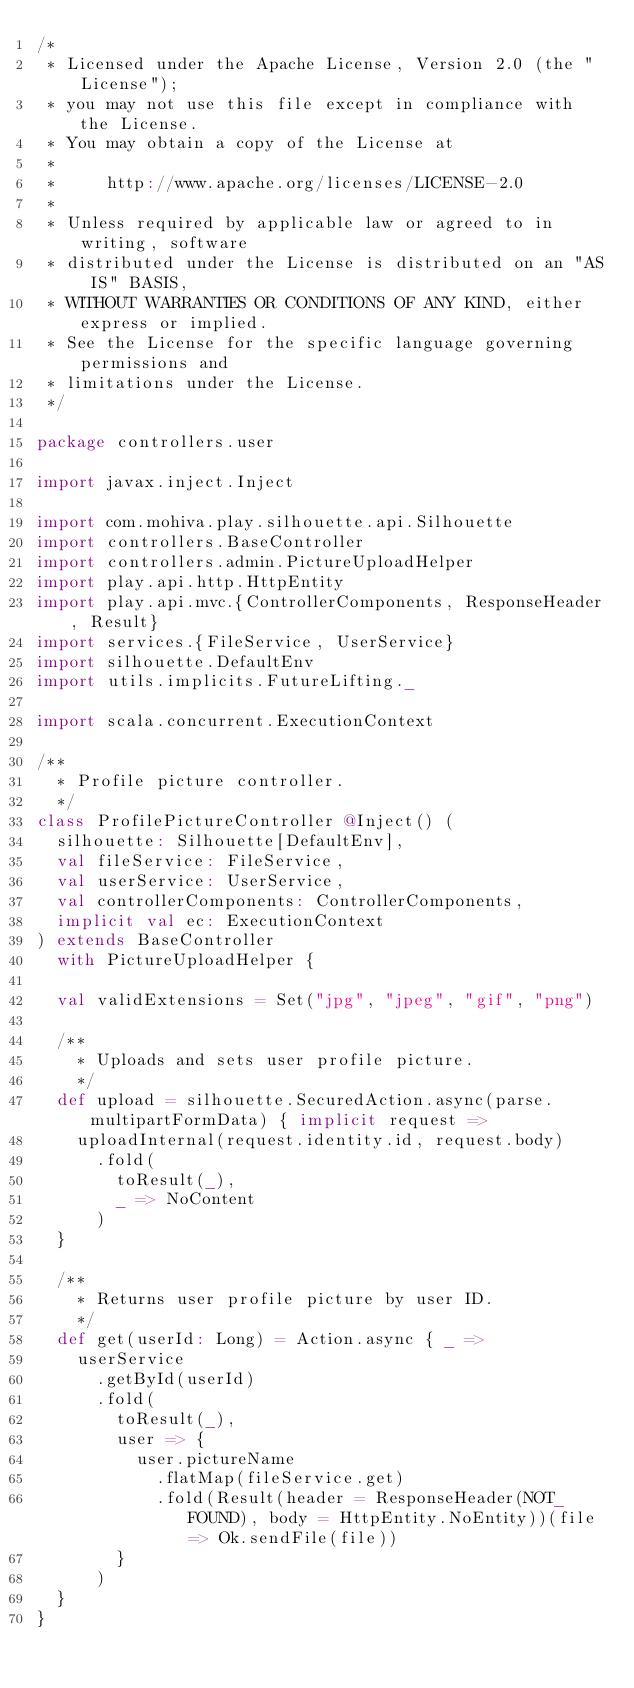Convert code to text. <code><loc_0><loc_0><loc_500><loc_500><_Scala_>/*
 * Licensed under the Apache License, Version 2.0 (the "License");
 * you may not use this file except in compliance with the License.
 * You may obtain a copy of the License at
 *
 *     http://www.apache.org/licenses/LICENSE-2.0
 *
 * Unless required by applicable law or agreed to in writing, software
 * distributed under the License is distributed on an "AS IS" BASIS,
 * WITHOUT WARRANTIES OR CONDITIONS OF ANY KIND, either express or implied.
 * See the License for the specific language governing permissions and
 * limitations under the License.
 */

package controllers.user

import javax.inject.Inject

import com.mohiva.play.silhouette.api.Silhouette
import controllers.BaseController
import controllers.admin.PictureUploadHelper
import play.api.http.HttpEntity
import play.api.mvc.{ControllerComponents, ResponseHeader, Result}
import services.{FileService, UserService}
import silhouette.DefaultEnv
import utils.implicits.FutureLifting._

import scala.concurrent.ExecutionContext

/**
  * Profile picture controller.
  */
class ProfilePictureController @Inject() (
  silhouette: Silhouette[DefaultEnv],
  val fileService: FileService,
  val userService: UserService,
  val controllerComponents: ControllerComponents,
  implicit val ec: ExecutionContext
) extends BaseController
  with PictureUploadHelper {

  val validExtensions = Set("jpg", "jpeg", "gif", "png")

  /**
    * Uploads and sets user profile picture.
    */
  def upload = silhouette.SecuredAction.async(parse.multipartFormData) { implicit request =>
    uploadInternal(request.identity.id, request.body)
      .fold(
        toResult(_),
        _ => NoContent
      )
  }

  /**
    * Returns user profile picture by user ID.
    */
  def get(userId: Long) = Action.async { _ =>
    userService
      .getById(userId)
      .fold(
        toResult(_),
        user => {
          user.pictureName
            .flatMap(fileService.get)
            .fold(Result(header = ResponseHeader(NOT_FOUND), body = HttpEntity.NoEntity))(file => Ok.sendFile(file))
        }
      )
  }
}
</code> 